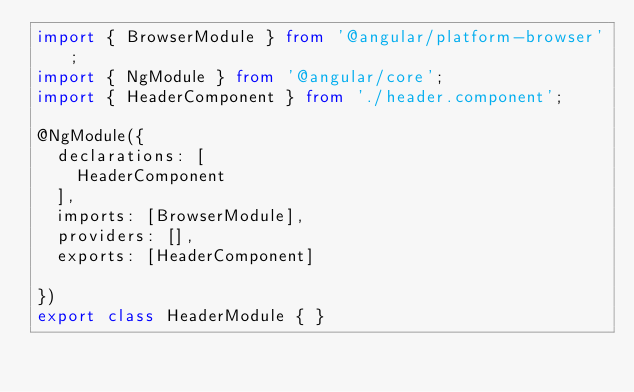Convert code to text. <code><loc_0><loc_0><loc_500><loc_500><_TypeScript_>import { BrowserModule } from '@angular/platform-browser';
import { NgModule } from '@angular/core';
import { HeaderComponent } from './header.component';

@NgModule({
  declarations: [
    HeaderComponent
  ],
  imports: [BrowserModule],
  providers: [],
  exports: [HeaderComponent]

})
export class HeaderModule { }
</code> 